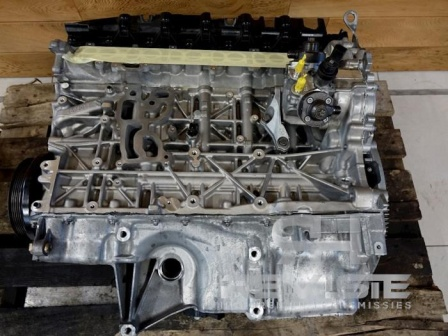Create a short fictional story inspired by the image, focusing on the engine block as the protagonist. In a bustling city, an old but sturdy engine block sat in a dimly lit garage, watching the modernity unfold around it. Once the heart of a classic muscle car, it had raced through city streets and roared across open highways. Now, detached and dusty, it yearned for the thrill of the road again. One day, a young engineer with a dream of restoring vintage cars stumbled upon it. Recognizing its potential, she began the painstaking process of cleaning, repairing, and upgrading. As the engine block was meticulously reassembled, it felt a renewed sense of purpose. Finally, installed in the car, the engine block roared back to life, ready to carve new memories on the asphalt. It wasn't just an old piece of machinery; it was a symbol of resilience and rebirth, a testament to the enduring spirit of the road. 